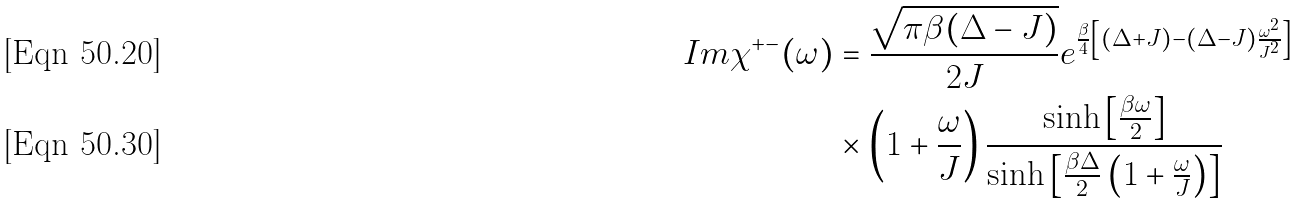Convert formula to latex. <formula><loc_0><loc_0><loc_500><loc_500>I m \chi ^ { + - } ( \omega ) & = \frac { \sqrt { \pi { \beta } ( \Delta - J ) } } { 2 J } e ^ { \frac { \beta } { 4 } \left [ ( \Delta + J ) - ( \Delta - J ) \frac { \omega ^ { 2 } } { J ^ { 2 } } \right ] } \\ & \times \left ( 1 + \frac { \omega } { J } \right ) \frac { \sinh \left [ \frac { \beta \omega } { 2 } \right ] } { \sinh \left [ \frac { \beta \Delta } { 2 } \left ( 1 + \frac { \omega } { J } \right ) \right ] }</formula> 